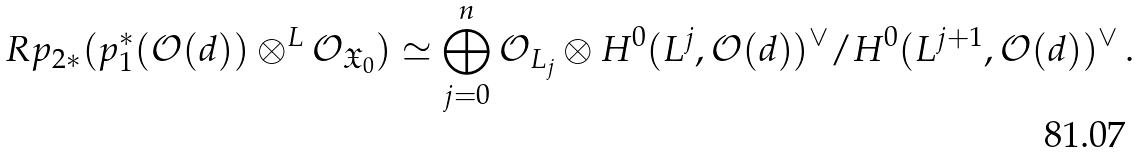<formula> <loc_0><loc_0><loc_500><loc_500>R p _ { 2 \ast } ( p _ { 1 } ^ { \ast } ( \mathcal { O } ( d ) ) \otimes ^ { L } \mathcal { O } _ { \mathfrak { X } _ { 0 } } ) \simeq \bigoplus _ { j = 0 } ^ { n } \mathcal { O } _ { L _ { j } } \otimes H ^ { 0 } ( L ^ { j } , \mathcal { O } ( d ) ) ^ { \vee } / H ^ { 0 } ( L ^ { j + 1 } , \mathcal { O } ( d ) ) ^ { \vee } \, .</formula> 